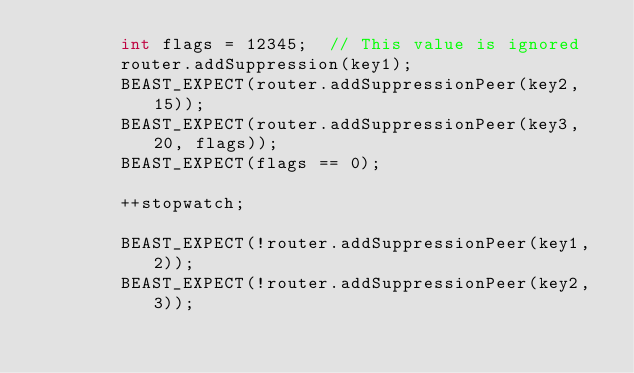<code> <loc_0><loc_0><loc_500><loc_500><_C++_>        int flags = 12345;  // This value is ignored
        router.addSuppression(key1);
        BEAST_EXPECT(router.addSuppressionPeer(key2, 15));
        BEAST_EXPECT(router.addSuppressionPeer(key3, 20, flags));
        BEAST_EXPECT(flags == 0);

        ++stopwatch;

        BEAST_EXPECT(!router.addSuppressionPeer(key1, 2));
        BEAST_EXPECT(!router.addSuppressionPeer(key2, 3));</code> 